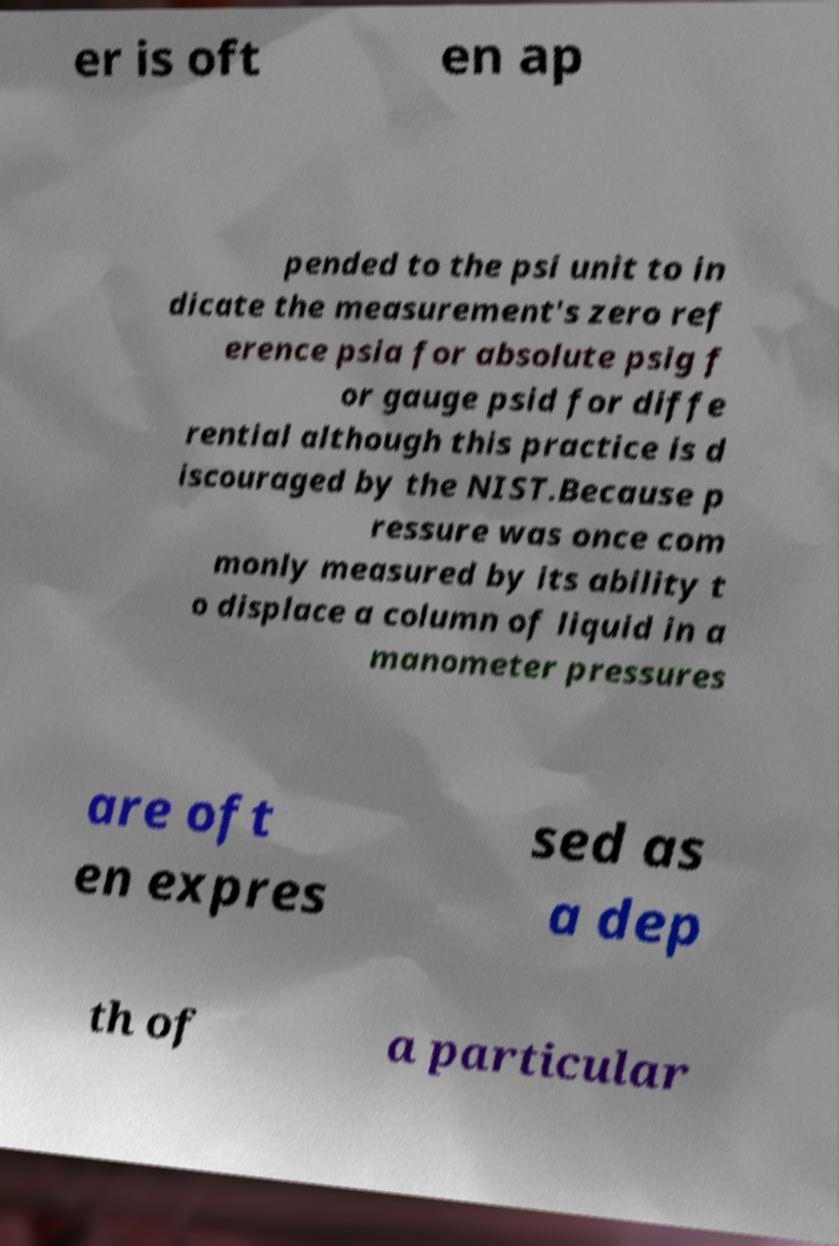Could you assist in decoding the text presented in this image and type it out clearly? er is oft en ap pended to the psi unit to in dicate the measurement's zero ref erence psia for absolute psig f or gauge psid for diffe rential although this practice is d iscouraged by the NIST.Because p ressure was once com monly measured by its ability t o displace a column of liquid in a manometer pressures are oft en expres sed as a dep th of a particular 